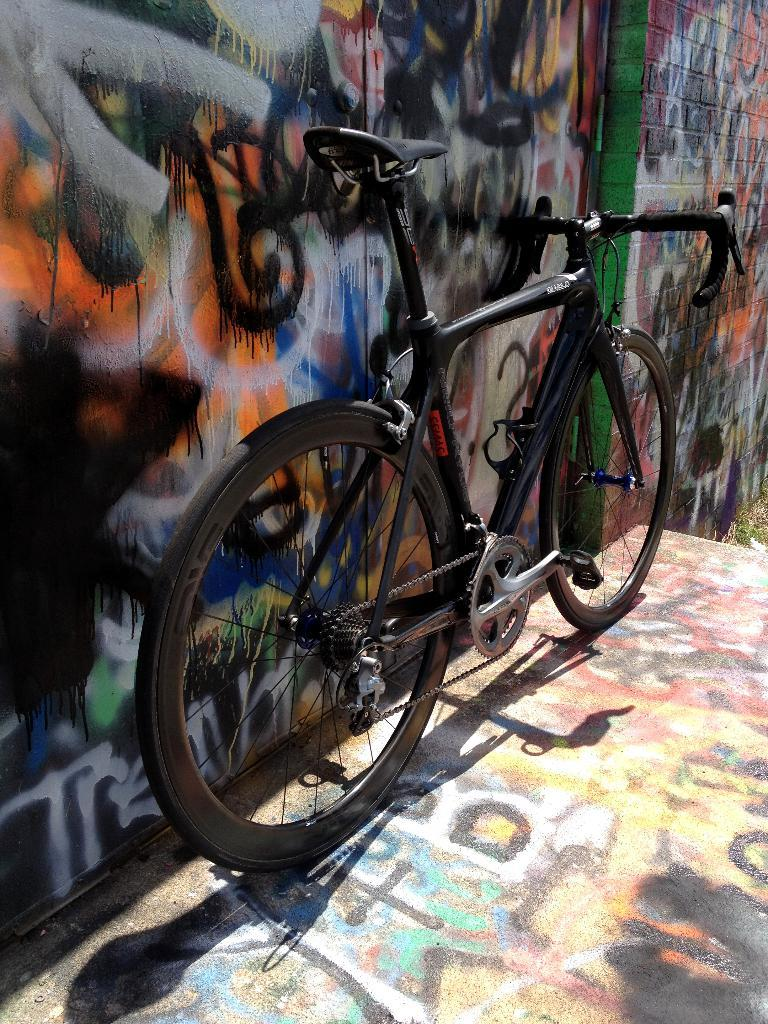What is the main subject in the center of the image? There is a bicycle in the center of the image. What can be seen on the wall in the background of the image? There is graffiti on the wall in the background of the image. What else in the background of the image has graffiti on it? There is graffiti on the floor in the background of the image. What degree does the uncle have in the image? There is no uncle or degree mentioned in the image. What is the uncle looking at in the image? There is no uncle or any indication of someone looking at something in the image. 